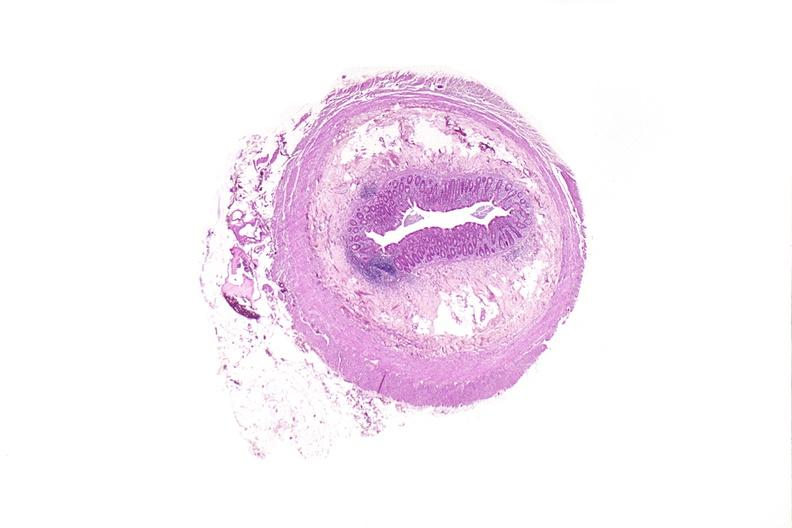s iron present?
Answer the question using a single word or phrase. No 